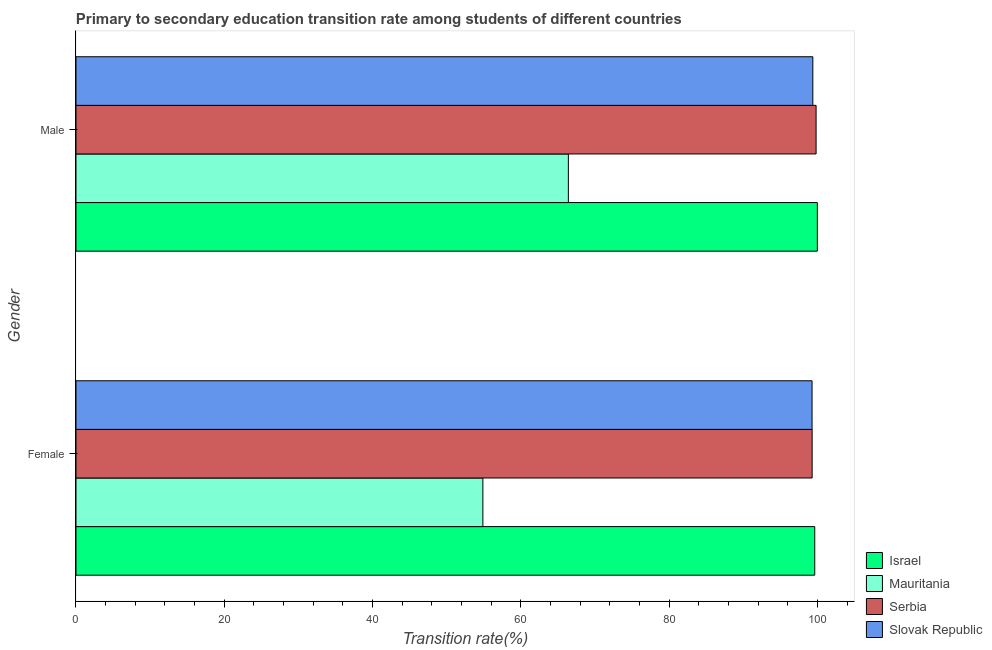How many groups of bars are there?
Offer a very short reply. 2. Are the number of bars on each tick of the Y-axis equal?
Ensure brevity in your answer.  Yes. How many bars are there on the 2nd tick from the top?
Make the answer very short. 4. Across all countries, what is the maximum transition rate among female students?
Your response must be concise. 99.65. Across all countries, what is the minimum transition rate among female students?
Offer a terse response. 54.88. In which country was the transition rate among male students maximum?
Make the answer very short. Israel. In which country was the transition rate among male students minimum?
Give a very brief answer. Mauritania. What is the total transition rate among male students in the graph?
Keep it short and to the point. 365.64. What is the difference between the transition rate among female students in Serbia and that in Israel?
Ensure brevity in your answer.  -0.35. What is the difference between the transition rate among female students in Slovak Republic and the transition rate among male students in Mauritania?
Your answer should be very brief. 32.87. What is the average transition rate among female students per country?
Your response must be concise. 88.28. What is the difference between the transition rate among female students and transition rate among male students in Israel?
Your answer should be compact. -0.35. In how many countries, is the transition rate among male students greater than 96 %?
Provide a succinct answer. 3. What is the ratio of the transition rate among female students in Serbia to that in Israel?
Ensure brevity in your answer.  1. Is the transition rate among female students in Slovak Republic less than that in Serbia?
Make the answer very short. Yes. In how many countries, is the transition rate among male students greater than the average transition rate among male students taken over all countries?
Give a very brief answer. 3. What does the 3rd bar from the top in Female represents?
Provide a short and direct response. Mauritania. What does the 4th bar from the bottom in Female represents?
Give a very brief answer. Slovak Republic. Are all the bars in the graph horizontal?
Keep it short and to the point. Yes. Where does the legend appear in the graph?
Your answer should be compact. Bottom right. How are the legend labels stacked?
Provide a short and direct response. Vertical. What is the title of the graph?
Provide a short and direct response. Primary to secondary education transition rate among students of different countries. Does "Lower middle income" appear as one of the legend labels in the graph?
Provide a short and direct response. No. What is the label or title of the X-axis?
Provide a short and direct response. Transition rate(%). What is the Transition rate(%) of Israel in Female?
Ensure brevity in your answer.  99.65. What is the Transition rate(%) in Mauritania in Female?
Make the answer very short. 54.88. What is the Transition rate(%) of Serbia in Female?
Your answer should be compact. 99.3. What is the Transition rate(%) in Slovak Republic in Female?
Offer a terse response. 99.29. What is the Transition rate(%) in Israel in Male?
Your answer should be compact. 100. What is the Transition rate(%) in Mauritania in Male?
Your answer should be very brief. 66.41. What is the Transition rate(%) of Serbia in Male?
Keep it short and to the point. 99.83. What is the Transition rate(%) in Slovak Republic in Male?
Ensure brevity in your answer.  99.39. Across all Gender, what is the maximum Transition rate(%) in Israel?
Make the answer very short. 100. Across all Gender, what is the maximum Transition rate(%) of Mauritania?
Your answer should be very brief. 66.41. Across all Gender, what is the maximum Transition rate(%) in Serbia?
Your response must be concise. 99.83. Across all Gender, what is the maximum Transition rate(%) of Slovak Republic?
Your response must be concise. 99.39. Across all Gender, what is the minimum Transition rate(%) in Israel?
Provide a succinct answer. 99.65. Across all Gender, what is the minimum Transition rate(%) of Mauritania?
Provide a succinct answer. 54.88. Across all Gender, what is the minimum Transition rate(%) of Serbia?
Provide a short and direct response. 99.3. Across all Gender, what is the minimum Transition rate(%) of Slovak Republic?
Ensure brevity in your answer.  99.29. What is the total Transition rate(%) of Israel in the graph?
Offer a very short reply. 199.65. What is the total Transition rate(%) of Mauritania in the graph?
Keep it short and to the point. 121.3. What is the total Transition rate(%) in Serbia in the graph?
Provide a succinct answer. 199.13. What is the total Transition rate(%) of Slovak Republic in the graph?
Make the answer very short. 198.68. What is the difference between the Transition rate(%) of Israel in Female and that in Male?
Offer a terse response. -0.35. What is the difference between the Transition rate(%) of Mauritania in Female and that in Male?
Your response must be concise. -11.53. What is the difference between the Transition rate(%) of Serbia in Female and that in Male?
Ensure brevity in your answer.  -0.53. What is the difference between the Transition rate(%) in Slovak Republic in Female and that in Male?
Provide a succinct answer. -0.1. What is the difference between the Transition rate(%) of Israel in Female and the Transition rate(%) of Mauritania in Male?
Offer a very short reply. 33.24. What is the difference between the Transition rate(%) of Israel in Female and the Transition rate(%) of Serbia in Male?
Offer a terse response. -0.18. What is the difference between the Transition rate(%) of Israel in Female and the Transition rate(%) of Slovak Republic in Male?
Give a very brief answer. 0.26. What is the difference between the Transition rate(%) in Mauritania in Female and the Transition rate(%) in Serbia in Male?
Make the answer very short. -44.95. What is the difference between the Transition rate(%) in Mauritania in Female and the Transition rate(%) in Slovak Republic in Male?
Your response must be concise. -44.51. What is the difference between the Transition rate(%) of Serbia in Female and the Transition rate(%) of Slovak Republic in Male?
Provide a short and direct response. -0.09. What is the average Transition rate(%) in Israel per Gender?
Provide a short and direct response. 99.83. What is the average Transition rate(%) of Mauritania per Gender?
Your answer should be very brief. 60.65. What is the average Transition rate(%) in Serbia per Gender?
Make the answer very short. 99.56. What is the average Transition rate(%) of Slovak Republic per Gender?
Provide a short and direct response. 99.34. What is the difference between the Transition rate(%) of Israel and Transition rate(%) of Mauritania in Female?
Your answer should be compact. 44.77. What is the difference between the Transition rate(%) in Israel and Transition rate(%) in Serbia in Female?
Provide a short and direct response. 0.35. What is the difference between the Transition rate(%) of Israel and Transition rate(%) of Slovak Republic in Female?
Provide a short and direct response. 0.36. What is the difference between the Transition rate(%) of Mauritania and Transition rate(%) of Serbia in Female?
Make the answer very short. -44.42. What is the difference between the Transition rate(%) in Mauritania and Transition rate(%) in Slovak Republic in Female?
Make the answer very short. -44.4. What is the difference between the Transition rate(%) of Serbia and Transition rate(%) of Slovak Republic in Female?
Keep it short and to the point. 0.01. What is the difference between the Transition rate(%) of Israel and Transition rate(%) of Mauritania in Male?
Keep it short and to the point. 33.59. What is the difference between the Transition rate(%) in Israel and Transition rate(%) in Serbia in Male?
Your answer should be compact. 0.17. What is the difference between the Transition rate(%) of Israel and Transition rate(%) of Slovak Republic in Male?
Your response must be concise. 0.61. What is the difference between the Transition rate(%) in Mauritania and Transition rate(%) in Serbia in Male?
Make the answer very short. -33.42. What is the difference between the Transition rate(%) of Mauritania and Transition rate(%) of Slovak Republic in Male?
Your answer should be compact. -32.98. What is the difference between the Transition rate(%) in Serbia and Transition rate(%) in Slovak Republic in Male?
Keep it short and to the point. 0.44. What is the ratio of the Transition rate(%) in Mauritania in Female to that in Male?
Offer a terse response. 0.83. What is the ratio of the Transition rate(%) of Serbia in Female to that in Male?
Give a very brief answer. 0.99. What is the ratio of the Transition rate(%) in Slovak Republic in Female to that in Male?
Offer a terse response. 1. What is the difference between the highest and the second highest Transition rate(%) in Israel?
Offer a very short reply. 0.35. What is the difference between the highest and the second highest Transition rate(%) of Mauritania?
Give a very brief answer. 11.53. What is the difference between the highest and the second highest Transition rate(%) in Serbia?
Your answer should be very brief. 0.53. What is the difference between the highest and the second highest Transition rate(%) in Slovak Republic?
Your answer should be very brief. 0.1. What is the difference between the highest and the lowest Transition rate(%) of Israel?
Your answer should be compact. 0.35. What is the difference between the highest and the lowest Transition rate(%) of Mauritania?
Your answer should be very brief. 11.53. What is the difference between the highest and the lowest Transition rate(%) of Serbia?
Ensure brevity in your answer.  0.53. What is the difference between the highest and the lowest Transition rate(%) of Slovak Republic?
Your answer should be compact. 0.1. 